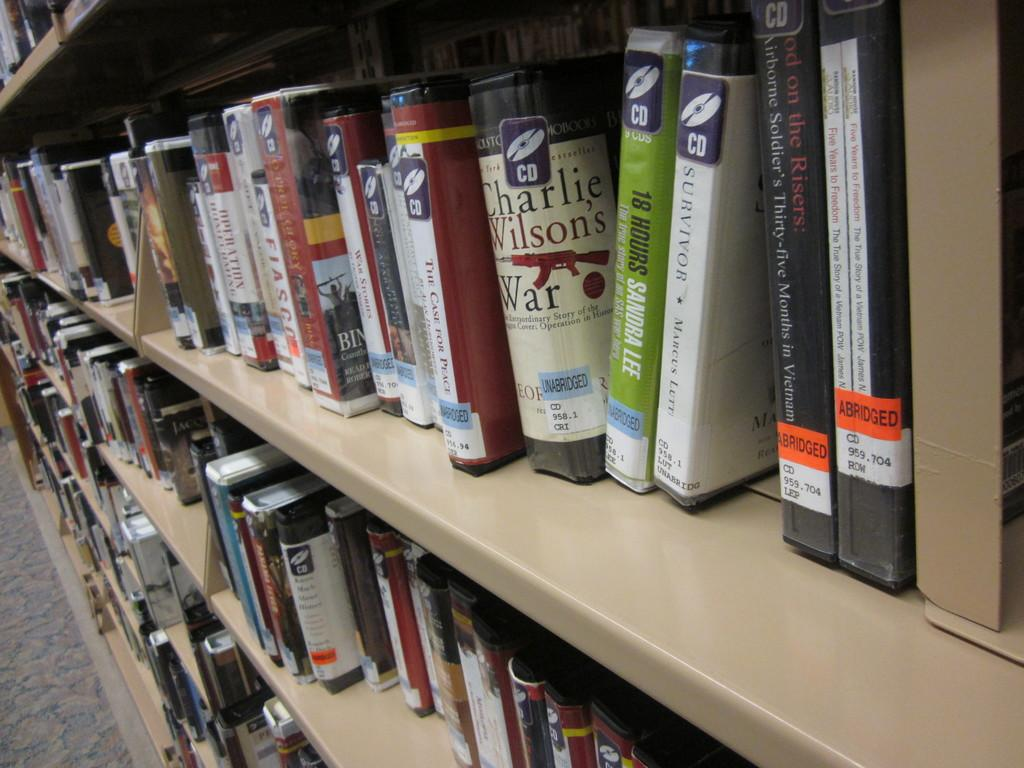What objects are visible in the image? There are different books in the image. How are the books arranged in the image? The books are kept in shelves. What type of coach can be seen in the image? There is no coach present in the image; it features different books kept in shelves. What action is required to start reading the books in the image? The image does not show any action or requirement to start reading the books; it only shows the books arranged in shelves. 